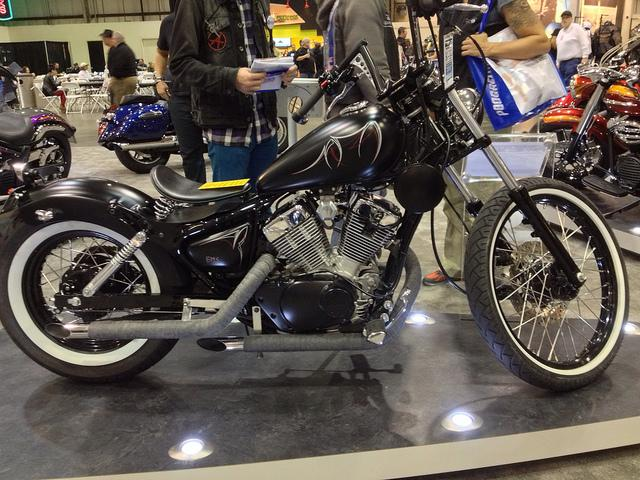What would you call the metal poles connecting to the front wheel? spokes 